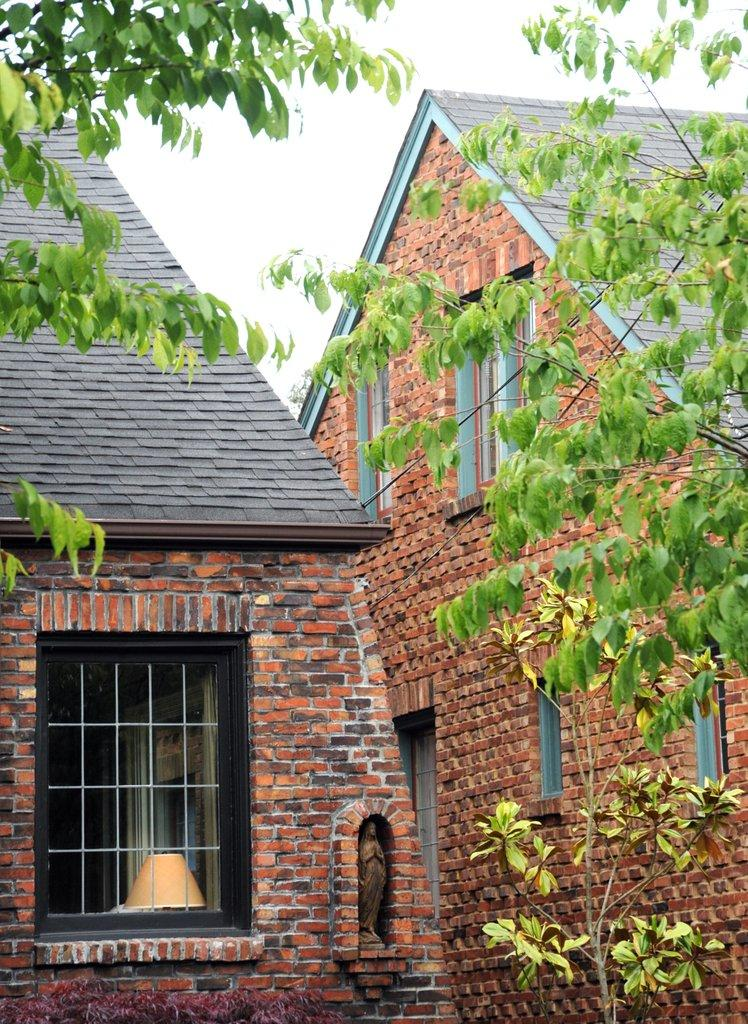What type of structure is present in the image? There is a house in the image. What features can be observed on the house? The house has a roof and windows. What other objects are present in the image? There is a statue, a lamp, and plants visible in the image. What can be seen in the background of the image? The sky is visible in the image, and it appears to be cloudy. What is the distribution of low-cost housing in the image? There is no information about low-cost housing in the image; it only features a house, a statue, a lamp, plants, and a cloudy sky. 